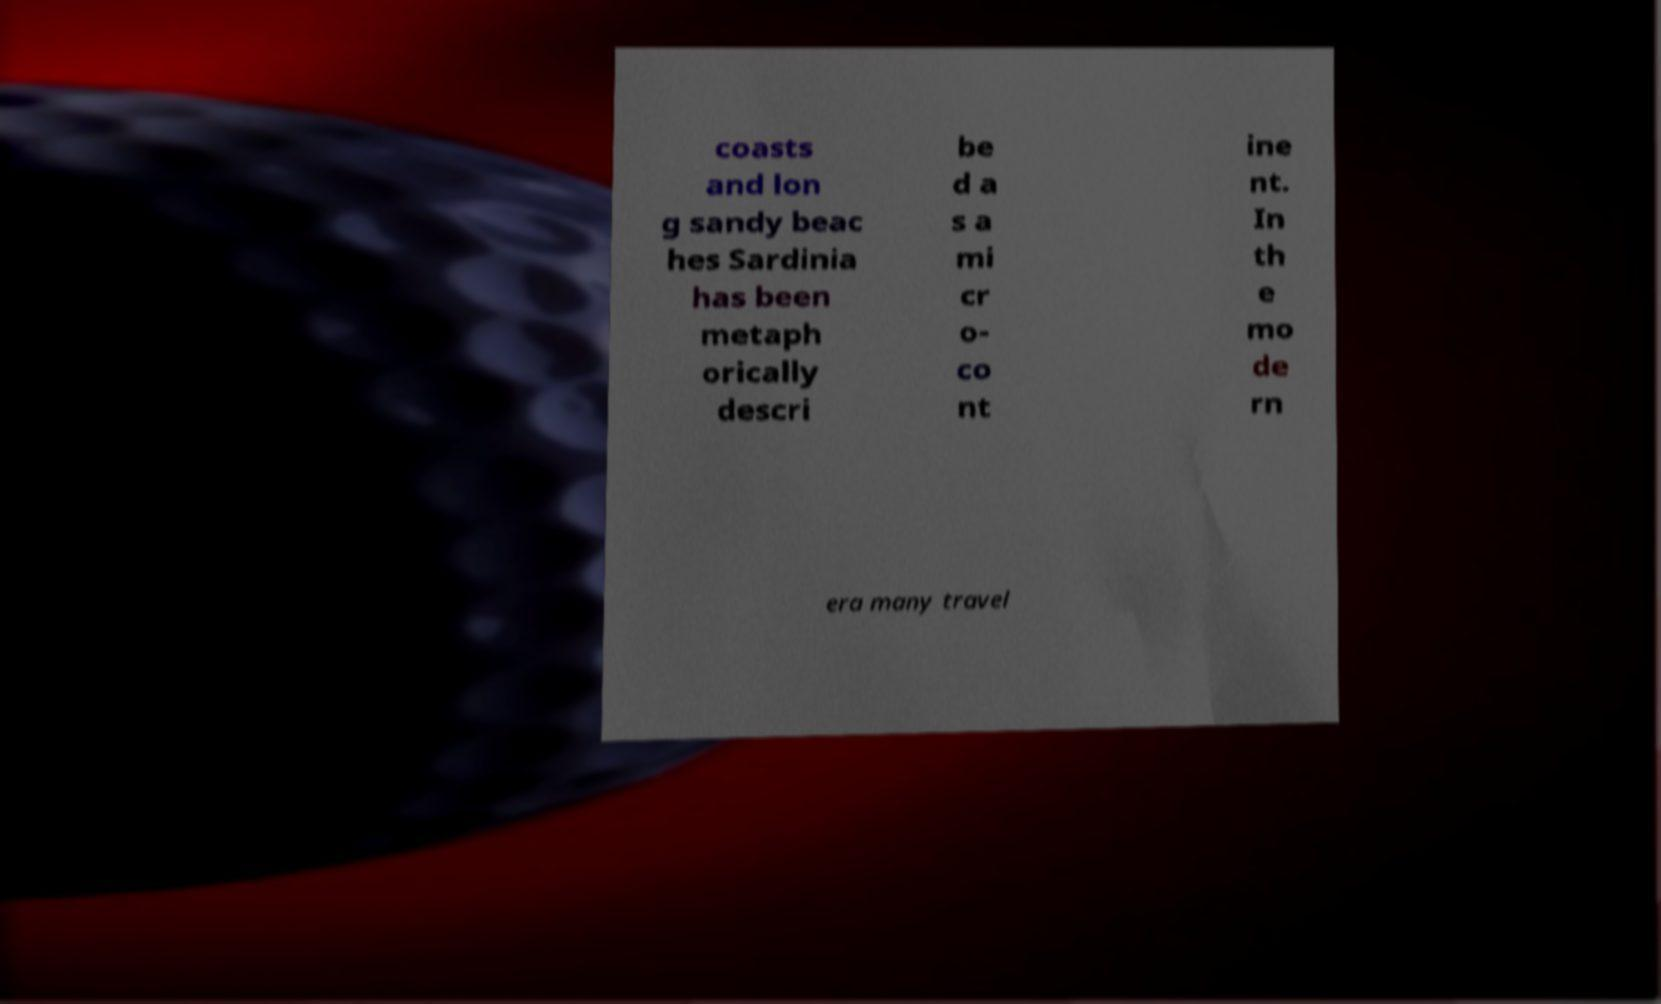I need the written content from this picture converted into text. Can you do that? coasts and lon g sandy beac hes Sardinia has been metaph orically descri be d a s a mi cr o- co nt ine nt. In th e mo de rn era many travel 